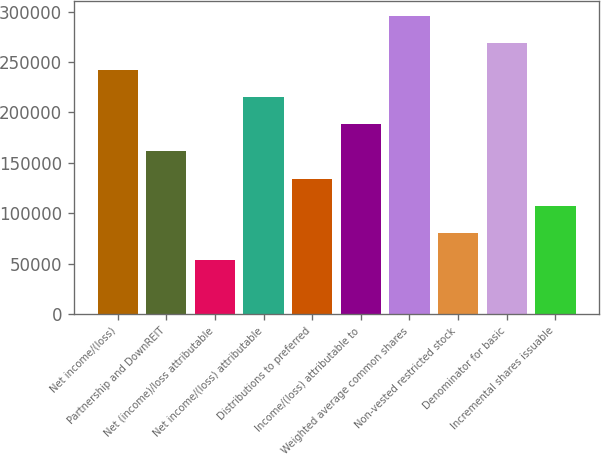<chart> <loc_0><loc_0><loc_500><loc_500><bar_chart><fcel>Net income/(loss)<fcel>Partnership and DownREIT<fcel>Net (income)/loss attributable<fcel>Net income/(loss) attributable<fcel>Distributions to preferred<fcel>Income/(loss) attributable to<fcel>Weighted average common shares<fcel>Non-vested restricted stock<fcel>Denominator for basic<fcel>Incremental shares issuable<nl><fcel>241947<fcel>161298<fcel>53766.4<fcel>215064<fcel>134415<fcel>188181<fcel>295713<fcel>80649.3<fcel>268830<fcel>107532<nl></chart> 